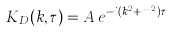Convert formula to latex. <formula><loc_0><loc_0><loc_500><loc_500>K _ { D } ( k , \tau ) = A \, e ^ { - i ( k ^ { 2 } + m ^ { 2 } ) \tau }</formula> 